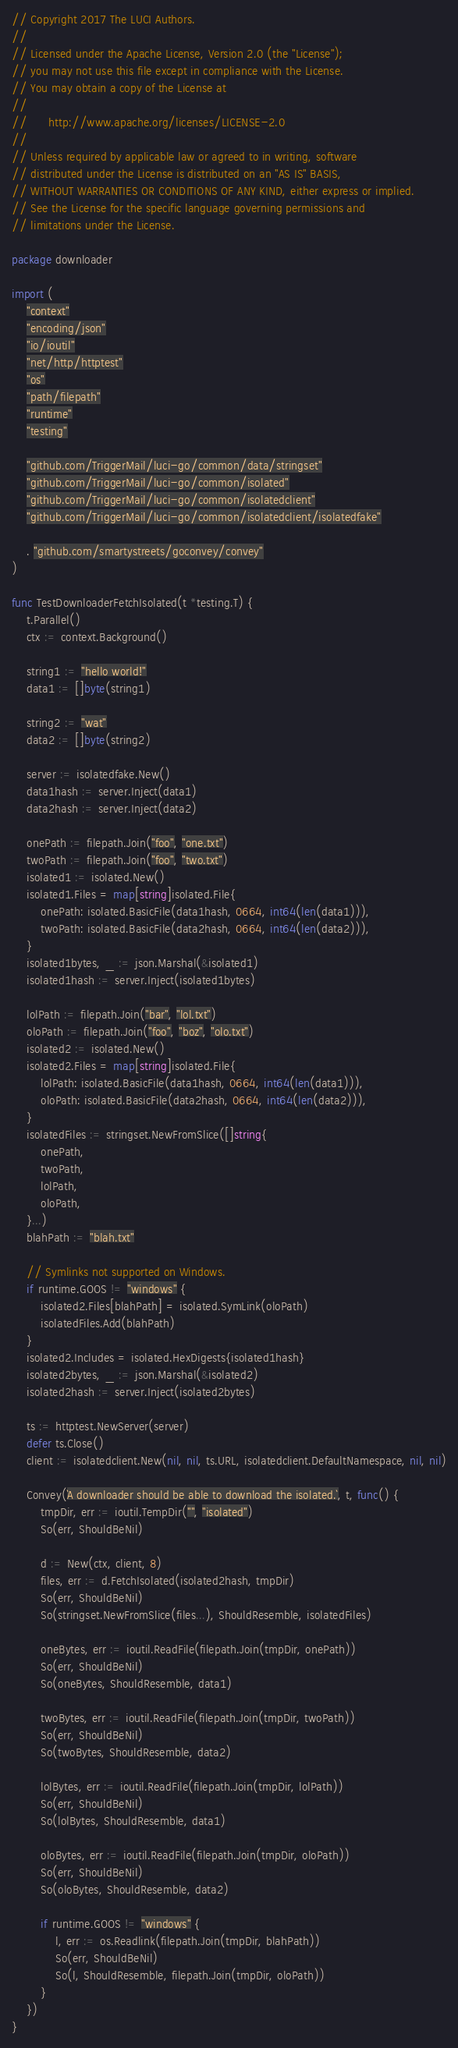<code> <loc_0><loc_0><loc_500><loc_500><_Go_>// Copyright 2017 The LUCI Authors.
//
// Licensed under the Apache License, Version 2.0 (the "License");
// you may not use this file except in compliance with the License.
// You may obtain a copy of the License at
//
//      http://www.apache.org/licenses/LICENSE-2.0
//
// Unless required by applicable law or agreed to in writing, software
// distributed under the License is distributed on an "AS IS" BASIS,
// WITHOUT WARRANTIES OR CONDITIONS OF ANY KIND, either express or implied.
// See the License for the specific language governing permissions and
// limitations under the License.

package downloader

import (
	"context"
	"encoding/json"
	"io/ioutil"
	"net/http/httptest"
	"os"
	"path/filepath"
	"runtime"
	"testing"

	"github.com/TriggerMail/luci-go/common/data/stringset"
	"github.com/TriggerMail/luci-go/common/isolated"
	"github.com/TriggerMail/luci-go/common/isolatedclient"
	"github.com/TriggerMail/luci-go/common/isolatedclient/isolatedfake"

	. "github.com/smartystreets/goconvey/convey"
)

func TestDownloaderFetchIsolated(t *testing.T) {
	t.Parallel()
	ctx := context.Background()

	string1 := "hello world!"
	data1 := []byte(string1)

	string2 := "wat"
	data2 := []byte(string2)

	server := isolatedfake.New()
	data1hash := server.Inject(data1)
	data2hash := server.Inject(data2)

	onePath := filepath.Join("foo", "one.txt")
	twoPath := filepath.Join("foo", "two.txt")
	isolated1 := isolated.New()
	isolated1.Files = map[string]isolated.File{
		onePath: isolated.BasicFile(data1hash, 0664, int64(len(data1))),
		twoPath: isolated.BasicFile(data2hash, 0664, int64(len(data2))),
	}
	isolated1bytes, _ := json.Marshal(&isolated1)
	isolated1hash := server.Inject(isolated1bytes)

	lolPath := filepath.Join("bar", "lol.txt")
	oloPath := filepath.Join("foo", "boz", "olo.txt")
	isolated2 := isolated.New()
	isolated2.Files = map[string]isolated.File{
		lolPath: isolated.BasicFile(data1hash, 0664, int64(len(data1))),
		oloPath: isolated.BasicFile(data2hash, 0664, int64(len(data2))),
	}
	isolatedFiles := stringset.NewFromSlice([]string{
		onePath,
		twoPath,
		lolPath,
		oloPath,
	}...)
	blahPath := "blah.txt"

	// Symlinks not supported on Windows.
	if runtime.GOOS != "windows" {
		isolated2.Files[blahPath] = isolated.SymLink(oloPath)
		isolatedFiles.Add(blahPath)
	}
	isolated2.Includes = isolated.HexDigests{isolated1hash}
	isolated2bytes, _ := json.Marshal(&isolated2)
	isolated2hash := server.Inject(isolated2bytes)

	ts := httptest.NewServer(server)
	defer ts.Close()
	client := isolatedclient.New(nil, nil, ts.URL, isolatedclient.DefaultNamespace, nil, nil)

	Convey(`A downloader should be able to download the isolated.`, t, func() {
		tmpDir, err := ioutil.TempDir("", "isolated")
		So(err, ShouldBeNil)

		d := New(ctx, client, 8)
		files, err := d.FetchIsolated(isolated2hash, tmpDir)
		So(err, ShouldBeNil)
		So(stringset.NewFromSlice(files...), ShouldResemble, isolatedFiles)

		oneBytes, err := ioutil.ReadFile(filepath.Join(tmpDir, onePath))
		So(err, ShouldBeNil)
		So(oneBytes, ShouldResemble, data1)

		twoBytes, err := ioutil.ReadFile(filepath.Join(tmpDir, twoPath))
		So(err, ShouldBeNil)
		So(twoBytes, ShouldResemble, data2)

		lolBytes, err := ioutil.ReadFile(filepath.Join(tmpDir, lolPath))
		So(err, ShouldBeNil)
		So(lolBytes, ShouldResemble, data1)

		oloBytes, err := ioutil.ReadFile(filepath.Join(tmpDir, oloPath))
		So(err, ShouldBeNil)
		So(oloBytes, ShouldResemble, data2)

		if runtime.GOOS != "windows" {
			l, err := os.Readlink(filepath.Join(tmpDir, blahPath))
			So(err, ShouldBeNil)
			So(l, ShouldResemble, filepath.Join(tmpDir, oloPath))
		}
	})
}
</code> 